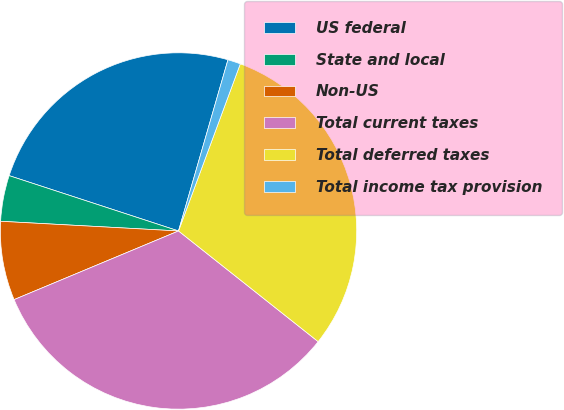<chart> <loc_0><loc_0><loc_500><loc_500><pie_chart><fcel>US federal<fcel>State and local<fcel>Non-US<fcel>Total current taxes<fcel>Total deferred taxes<fcel>Total income tax provision<nl><fcel>24.45%<fcel>4.16%<fcel>7.16%<fcel>33.04%<fcel>30.03%<fcel>1.16%<nl></chart> 